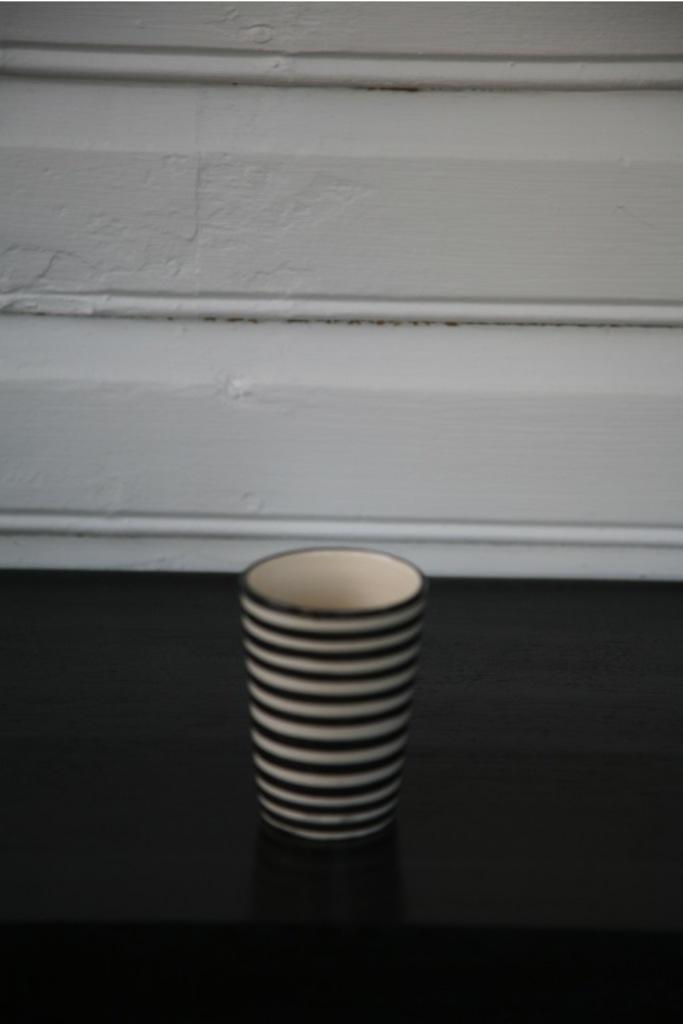Can you describe this image briefly? In this image I see a cup which is of black and white in color and it is on the black surface. In the background I see the white wall. 